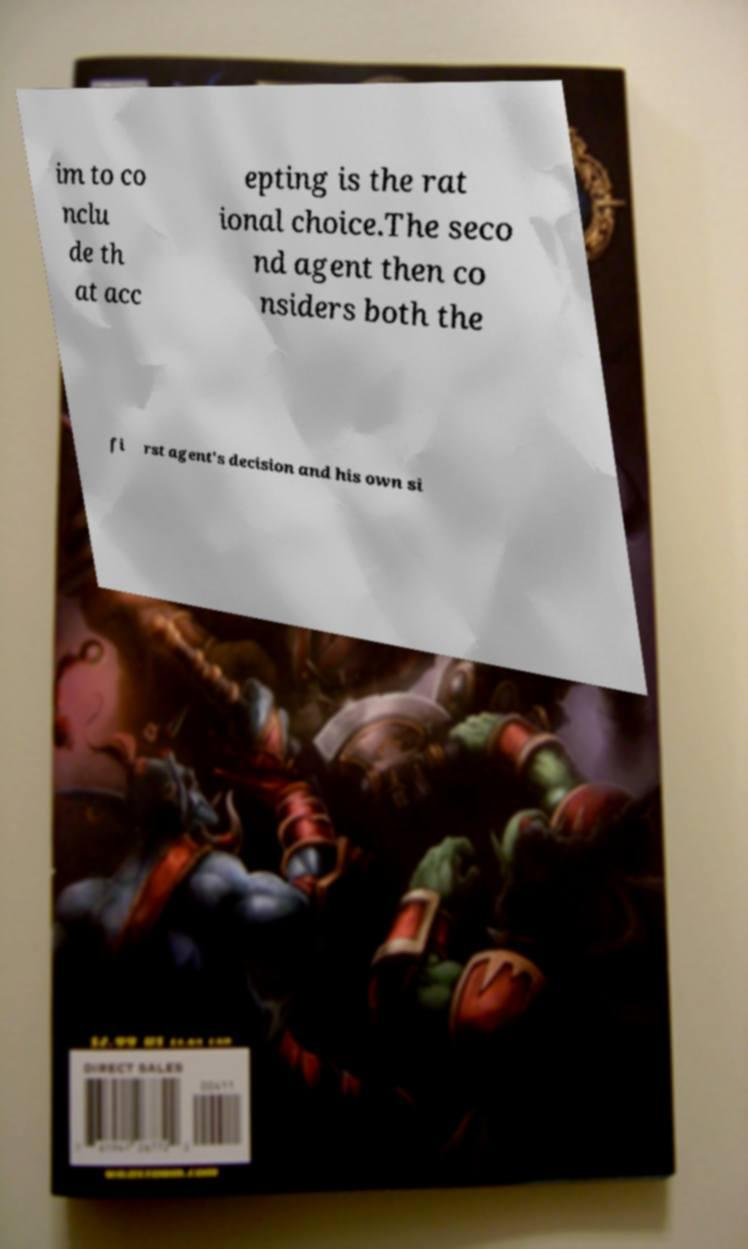I need the written content from this picture converted into text. Can you do that? im to co nclu de th at acc epting is the rat ional choice.The seco nd agent then co nsiders both the fi rst agent's decision and his own si 